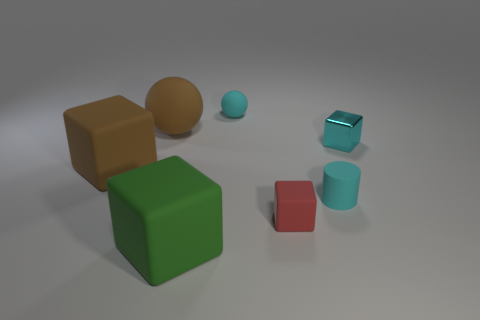Does the green thing have the same size as the brown ball?
Ensure brevity in your answer.  Yes. There is a large brown thing that is the same shape as the small red object; what is its material?
Offer a terse response. Rubber. Is there anything else that is made of the same material as the cyan sphere?
Keep it short and to the point. Yes. How many brown things are either big rubber things or spheres?
Make the answer very short. 2. There is a tiny thing left of the red matte object; what material is it?
Make the answer very short. Rubber. Is the number of gray rubber cylinders greater than the number of brown rubber objects?
Give a very brief answer. No. There is a small cyan object left of the cylinder; is it the same shape as the tiny cyan metallic object?
Your answer should be very brief. No. What number of objects are behind the shiny block and on the right side of the green matte object?
Keep it short and to the point. 1. What number of tiny red objects are the same shape as the cyan shiny thing?
Keep it short and to the point. 1. There is a small sphere on the right side of the block that is left of the green object; what is its color?
Your answer should be very brief. Cyan. 